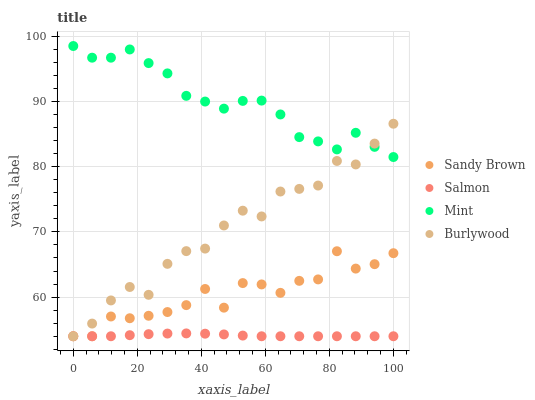Does Salmon have the minimum area under the curve?
Answer yes or no. Yes. Does Mint have the maximum area under the curve?
Answer yes or no. Yes. Does Sandy Brown have the minimum area under the curve?
Answer yes or no. No. Does Sandy Brown have the maximum area under the curve?
Answer yes or no. No. Is Salmon the smoothest?
Answer yes or no. Yes. Is Sandy Brown the roughest?
Answer yes or no. Yes. Is Sandy Brown the smoothest?
Answer yes or no. No. Is Salmon the roughest?
Answer yes or no. No. Does Burlywood have the lowest value?
Answer yes or no. Yes. Does Mint have the lowest value?
Answer yes or no. No. Does Mint have the highest value?
Answer yes or no. Yes. Does Sandy Brown have the highest value?
Answer yes or no. No. Is Sandy Brown less than Mint?
Answer yes or no. Yes. Is Mint greater than Sandy Brown?
Answer yes or no. Yes. Does Burlywood intersect Mint?
Answer yes or no. Yes. Is Burlywood less than Mint?
Answer yes or no. No. Is Burlywood greater than Mint?
Answer yes or no. No. Does Sandy Brown intersect Mint?
Answer yes or no. No. 